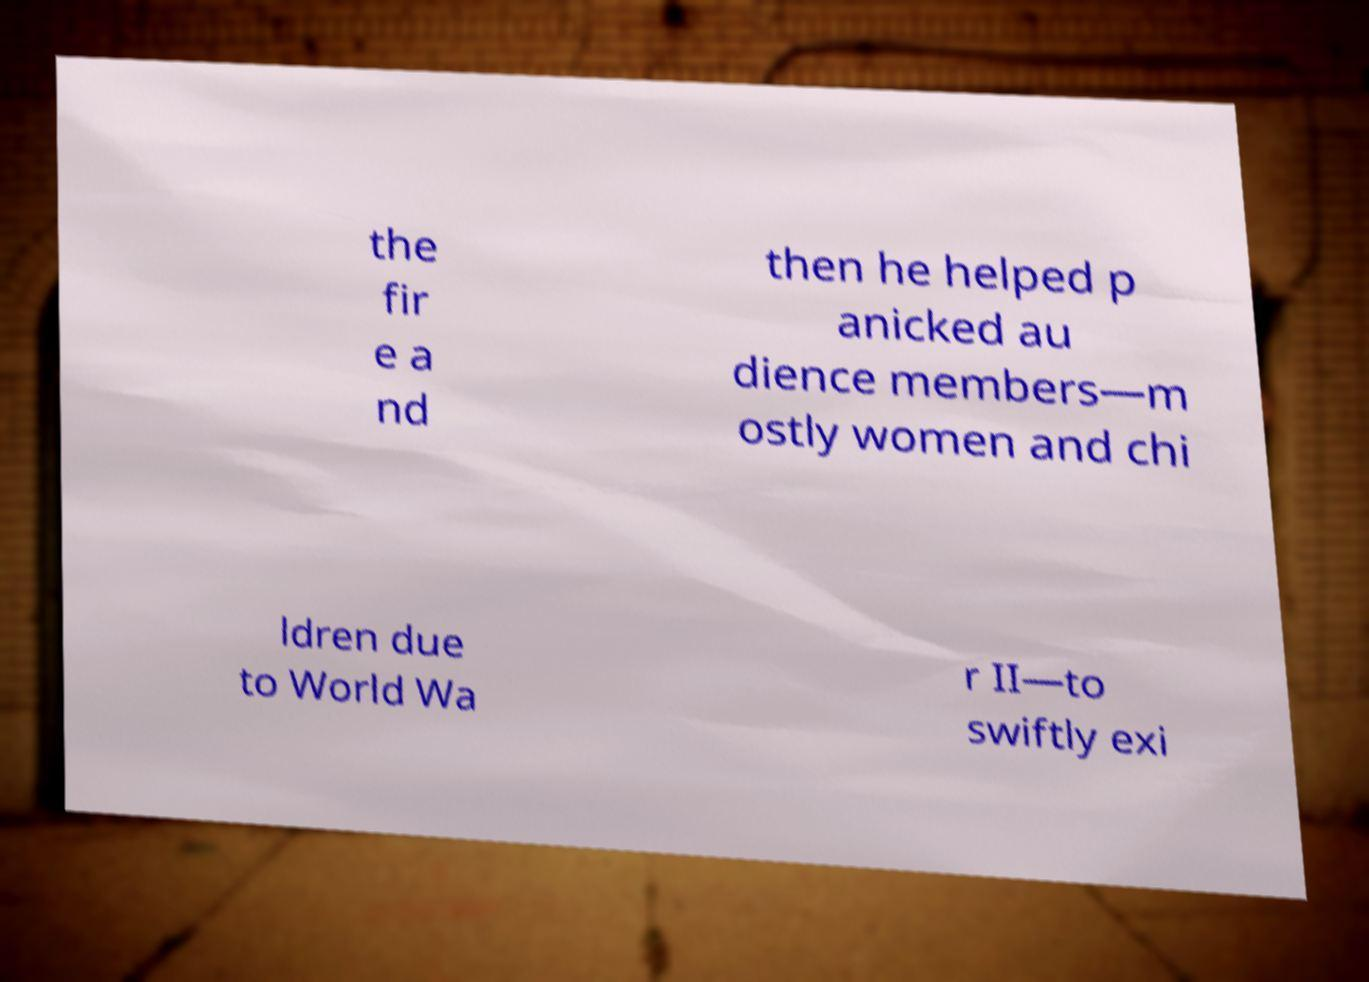Could you assist in decoding the text presented in this image and type it out clearly? the fir e a nd then he helped p anicked au dience members—m ostly women and chi ldren due to World Wa r II—to swiftly exi 